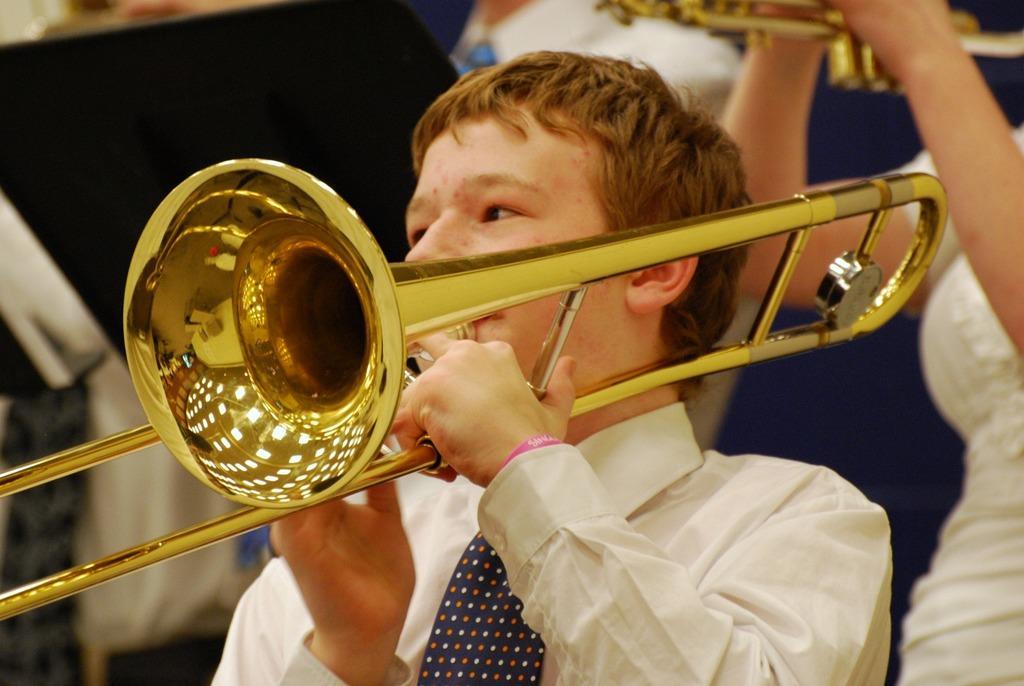Describe this image in one or two sentences. This picture seems to be clicked inside and we can see the two persons wearing white color dresses and playing trombone and seems to be standing. In the background there is a black color object and some other items. 